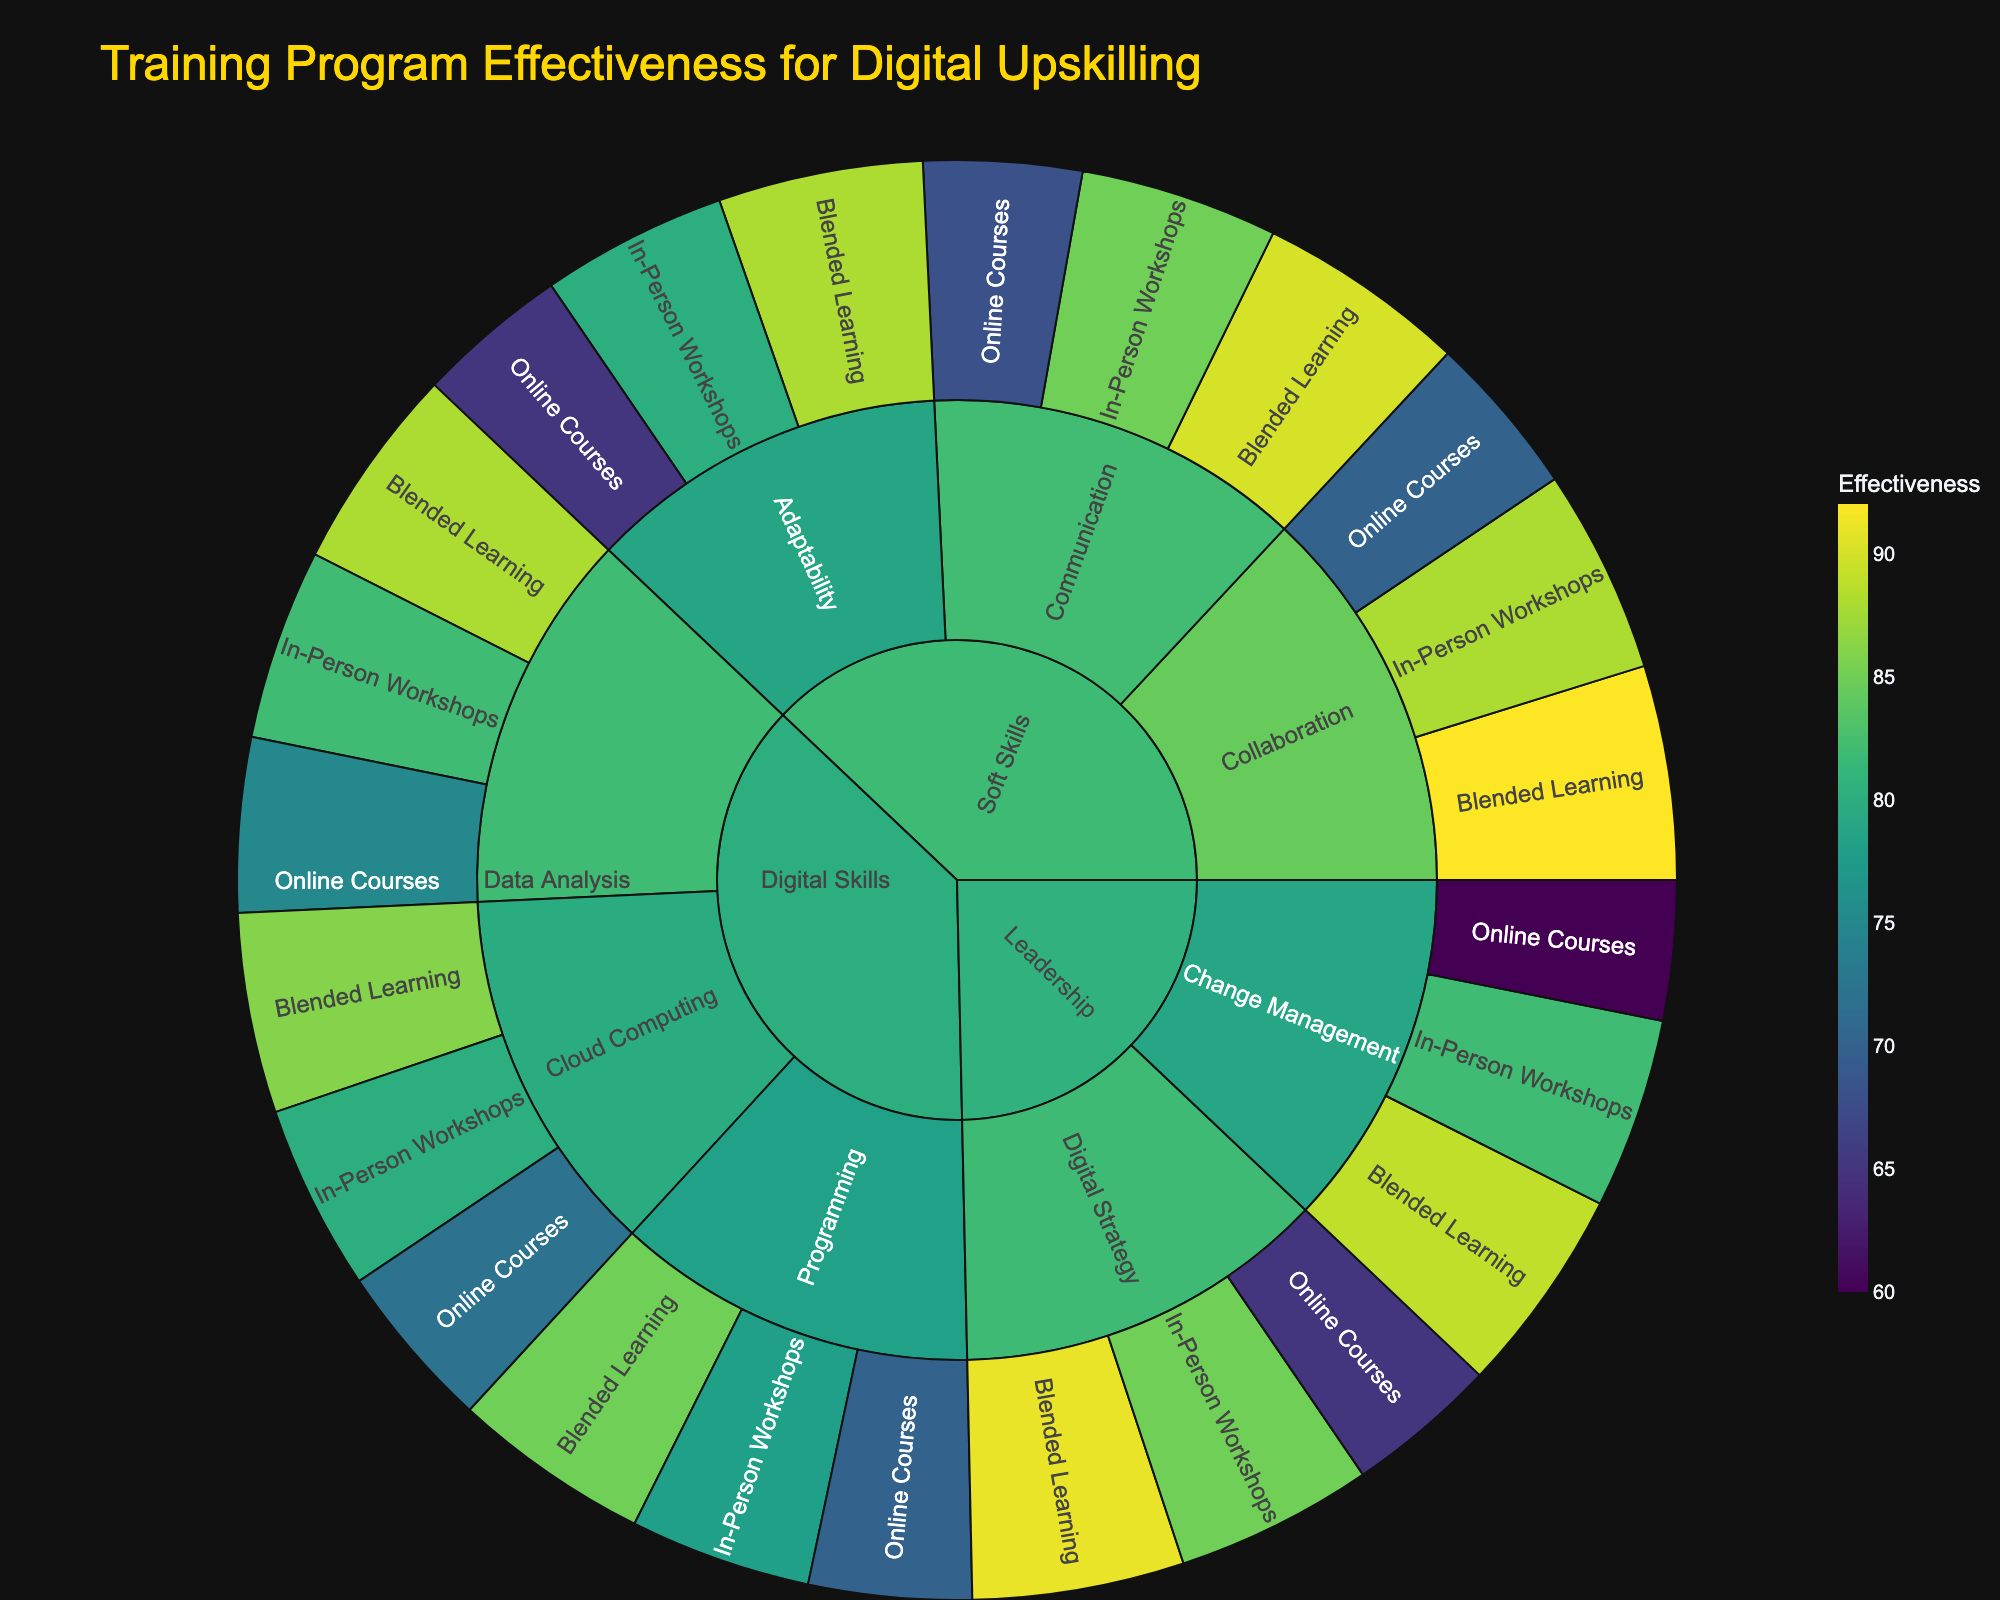What is the title of the figure? The title is usually at the top and provides an overview of the data being presented. In this case, look for the highlighted text at the very top of the figure.
Answer: Training Program Effectiveness for Digital Upskilling Which category has the highest effectiveness scores for Blended Learning? By looking at the effectiveness scores within the Blended Learning method branch, compare the values for each category and identify the highest scores.
Answer: Leadership (with Blended Learning for Digital Strategy at 91%) What is the effectiveness score for In-Person Workshops for Communication skills? Navigate through the Soft Skills category to the Communication subcategory and check the effectiveness score for the In-Person Workshops learning method.
Answer: 85% Compare the effectiveness of Blended Learning for Data Analysis and Programming. Which one is higher and by how much? Locate the effectiveness scores for Blended Learning under Digital Skills for both Data Analysis and Programming. Subtract the smaller value from the larger one.
Answer: Data Analysis is higher by 3% (88% - 85% = 3%) Which learning method has the lowest effectiveness score across all categories? Check the effectiveness scores across all categories and learning methods to find the minimum value.
Answer: Online Courses for Change Management (60%) What is the average effectiveness of Online Courses across all subcategories? Add up all the effectiveness scores for Online Courses across all subcategories, then divide by the number of subcategories.
Answer: (75 + 70 + 72 + 68 + 65 + 70 + 60 + 65) / 8 = 68.125 How does the effectiveness of In-Person Workshops for Cloud Computing compare to Online Courses for the same subcategory? Find the effectiveness scores for Cloud Computing under both In-Person Workshops and Online Courses, and determine the difference.
Answer: In-Person Workshops are 8% more effective than Online Courses (80% - 72% = 8%) What effectiveness value is represented by the darkest segment? In a color-coded plot, the darkest color usually corresponds to the highest value on a given color scale. Identify this segment and check its effectiveness value.
Answer: Blended Learning for Collaboration (92%) Identify the subcategories under the Leadership category and their highest effectiveness scores for any method. Look under the Leadership category and check the highest effectiveness scores for each subcategory across all learning methods.
Answer: Change Management (89%), Digital Strategy (91%) In the Digital Skills category, which subcategory's effectiveness shows the least variation across different methods? Compare the effectiveness scores for Data Analysis, Programming, and Cloud Computing in their respective learning methods and identify the subcategory with the smallest range.
Answer: Cloud Computing (difference between highest and lowest is 14%: 86% - 72%) 